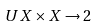Convert formula to latex. <formula><loc_0><loc_0><loc_500><loc_500>U X \times X \to 2</formula> 